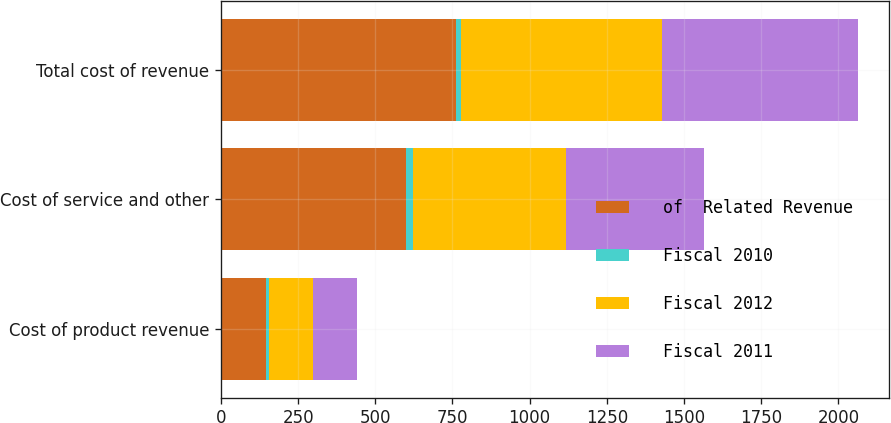Convert chart to OTSL. <chart><loc_0><loc_0><loc_500><loc_500><stacked_bar_chart><ecel><fcel>Cost of product revenue<fcel>Cost of service and other<fcel>Total cost of revenue<nl><fcel>of  Related Revenue<fcel>145<fcel>601<fcel>760<nl><fcel>Fiscal 2010<fcel>10<fcel>22<fcel>18<nl><fcel>Fiscal 2012<fcel>143<fcel>495<fcel>650<nl><fcel>Fiscal 2011<fcel>144<fcel>447<fcel>634<nl></chart> 